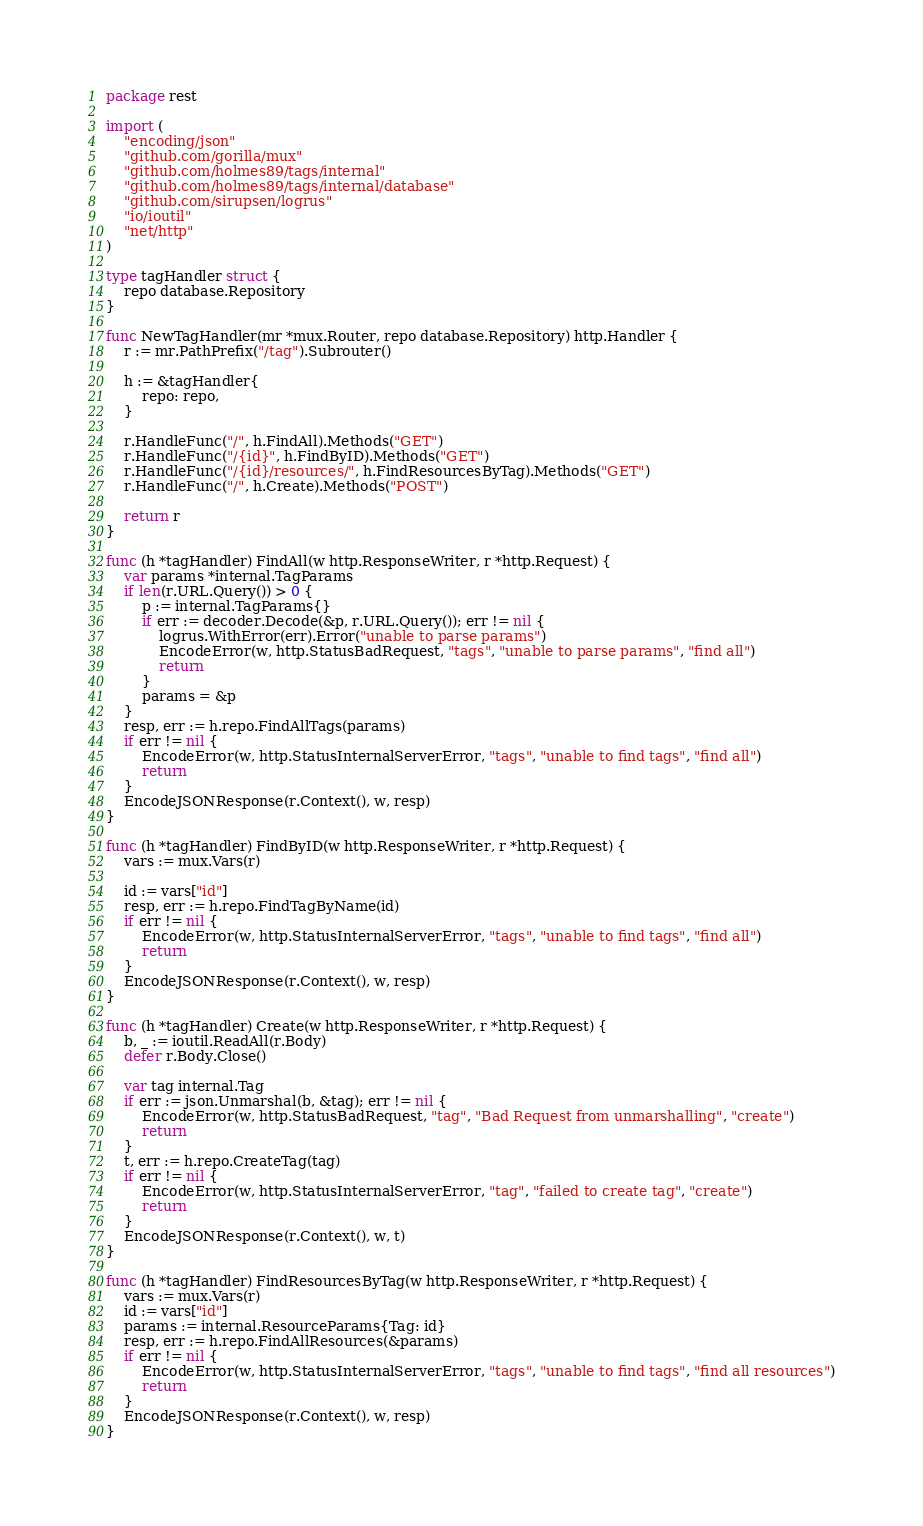Convert code to text. <code><loc_0><loc_0><loc_500><loc_500><_Go_>package rest

import (
	"encoding/json"
	"github.com/gorilla/mux"
	"github.com/holmes89/tags/internal"
	"github.com/holmes89/tags/internal/database"
	"github.com/sirupsen/logrus"
	"io/ioutil"
	"net/http"
)

type tagHandler struct {
	repo database.Repository
}

func NewTagHandler(mr *mux.Router, repo database.Repository) http.Handler {
	r := mr.PathPrefix("/tag").Subrouter()

	h := &tagHandler{
		repo: repo,
	}

	r.HandleFunc("/", h.FindAll).Methods("GET")
	r.HandleFunc("/{id}", h.FindByID).Methods("GET")
	r.HandleFunc("/{id}/resources/", h.FindResourcesByTag).Methods("GET")
	r.HandleFunc("/", h.Create).Methods("POST")

	return r
}

func (h *tagHandler) FindAll(w http.ResponseWriter, r *http.Request) {
	var params *internal.TagParams
	if len(r.URL.Query()) > 0 {
		p := internal.TagParams{}
		if err := decoder.Decode(&p, r.URL.Query()); err != nil {
			logrus.WithError(err).Error("unable to parse params")
			EncodeError(w, http.StatusBadRequest, "tags", "unable to parse params", "find all")
			return
		}
		params = &p
	}
	resp, err := h.repo.FindAllTags(params)
	if err != nil {
		EncodeError(w, http.StatusInternalServerError, "tags", "unable to find tags", "find all")
		return
	}
	EncodeJSONResponse(r.Context(), w, resp)
}

func (h *tagHandler) FindByID(w http.ResponseWriter, r *http.Request) {
	vars := mux.Vars(r)

	id := vars["id"]
	resp, err := h.repo.FindTagByName(id)
	if err != nil {
		EncodeError(w, http.StatusInternalServerError, "tags", "unable to find tags", "find all")
		return
	}
	EncodeJSONResponse(r.Context(), w, resp)
}

func (h *tagHandler) Create(w http.ResponseWriter, r *http.Request) {
	b, _ := ioutil.ReadAll(r.Body)
	defer r.Body.Close()

	var tag internal.Tag
	if err := json.Unmarshal(b, &tag); err != nil {
		EncodeError(w, http.StatusBadRequest, "tag", "Bad Request from unmarshalling", "create")
		return
	}
	t, err := h.repo.CreateTag(tag)
	if err != nil {
		EncodeError(w, http.StatusInternalServerError, "tag", "failed to create tag", "create")
		return
	}
	EncodeJSONResponse(r.Context(), w, t)
}

func (h *tagHandler) FindResourcesByTag(w http.ResponseWriter, r *http.Request) {
	vars := mux.Vars(r)
	id := vars["id"]
	params := internal.ResourceParams{Tag: id}
	resp, err := h.repo.FindAllResources(&params)
	if err != nil {
		EncodeError(w, http.StatusInternalServerError, "tags", "unable to find tags", "find all resources")
		return
	}
	EncodeJSONResponse(r.Context(), w, resp)
}
</code> 